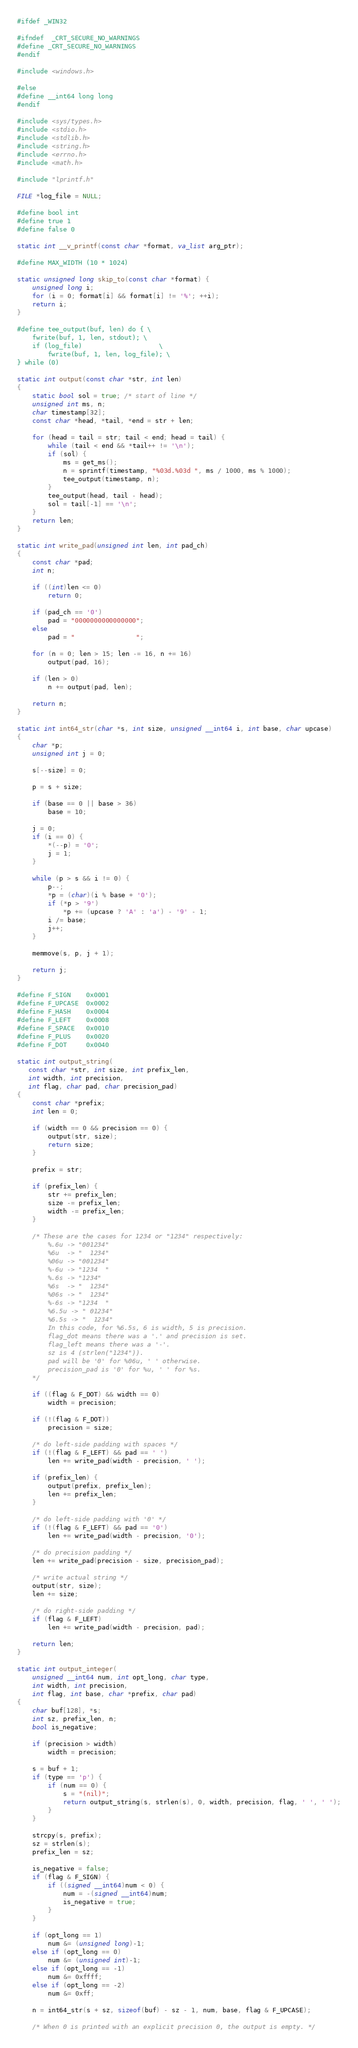Convert code to text. <code><loc_0><loc_0><loc_500><loc_500><_C_>
#ifdef _WIN32

#ifndef	_CRT_SECURE_NO_WARNINGS
#define _CRT_SECURE_NO_WARNINGS
#endif

#include <windows.h>

#else
#define __int64 long long
#endif

#include <sys/types.h>
#include <stdio.h>
#include <stdlib.h>
#include <string.h>
#include <errno.h>
#include <math.h>

#include "lprintf.h"

FILE *log_file = NULL;

#define bool int
#define true 1
#define false 0

static int __v_printf(const char *format, va_list arg_ptr);

#define MAX_WIDTH (10 * 1024)

static unsigned long skip_to(const char *format) {
    unsigned long i;
    for (i = 0; format[i] && format[i] != '%'; ++i);
    return i;
}

#define tee_output(buf, len) do { \
    fwrite(buf, 1, len, stdout); \
	if (log_file)                    \
        fwrite(buf, 1, len, log_file); \
} while (0)

static int output(const char *str, int len)
{
	static bool sol = true; /* start of line */
	unsigned int ms, n;
	char timestamp[32];
	const char *head, *tail, *end = str + len;

	for (head = tail = str; tail < end; head = tail) {
		while (tail < end && *tail++ != '\n');
		if (sol) {
			ms = get_ms();
			n = sprintf(timestamp, "%03d.%03d ", ms / 1000, ms % 1000);
			tee_output(timestamp, n);
		}
		tee_output(head, tail - head);
		sol = tail[-1] == '\n';
	}
	return len;
}

static int write_pad(unsigned int len, int pad_ch) 
{
    const char *pad;
    int n;

    if ((int)len <= 0) 
        return 0;

    if (pad_ch == '0')
        pad = "0000000000000000";
    else
        pad = "                ";

    for (n = 0; len > 15; len -= 16, n += 16) 
        output(pad, 16);

    if (len > 0) 
        n += output(pad, len); 

    return n;
}

static int int64_str(char *s, int size, unsigned __int64 i, int base, char upcase)
{
    char *p;
    unsigned int j = 0;
    
    s[--size] = 0; 
    
    p = s + size;
    
    if (base == 0 || base > 36) 
        base = 10;
    
    j = 0;
    if (i == 0) {
        *(--p) = '0';
        j = 1;
    }
    
    while (p > s && i != 0) {
        p--;
        *p = (char)(i % base + '0');
        if (*p > '9') 
            *p += (upcase ? 'A' : 'a') - '9' - 1;
        i /= base;
        j++;
    }

    memmove(s, p, j + 1);

    return j;
}

#define F_SIGN    0x0001
#define F_UPCASE  0x0002
#define F_HASH    0x0004
#define F_LEFT    0x0008
#define F_SPACE   0x0010
#define F_PLUS    0x0020
#define F_DOT     0x0040

static int output_string(
   const char *str, int size, int prefix_len, 
   int width, int precision, 
   int flag, char pad, char precision_pad)
{
    const char *prefix;
    int len = 0;

    if (width == 0 && precision == 0) {
        output(str, size); 
        return size;
    }
    
    prefix = str;
    
    if (prefix_len) {
        str += prefix_len;
        size -= prefix_len;
        width -= prefix_len;
    }
    
    /* These are the cases for 1234 or "1234" respectively:
        %.6u -> "001234"
        %6u  -> "  1234"
        %06u -> "001234"
        %-6u -> "1234  "
        %.6s -> "1234"
        %6s  -> "  1234"
        %06s -> "  1234"
        %-6s -> "1234  "
        %6.5u -> " 01234"
        %6.5s -> "  1234"
        In this code, for %6.5s, 6 is width, 5 is precision.
        flag_dot means there was a '.' and precision is set.
        flag_left means there was a '-'.
        sz is 4 (strlen("1234")).
        pad will be '0' for %06u, ' ' otherwise.
        precision_pad is '0' for %u, ' ' for %s.
    */
    
    if ((flag & F_DOT) && width == 0) 
        width = precision;
    
    if (!(flag & F_DOT)) 
        precision = size;

    /* do left-side padding with spaces */
    if (!(flag & F_LEFT) && pad == ' ') 
        len += write_pad(width - precision, ' ');
    
    if (prefix_len) {
        output(prefix, prefix_len);
        len += prefix_len;
    }

    /* do left-side padding with '0' */
    if (!(flag & F_LEFT) && pad == '0') 
        len += write_pad(width - precision, '0');
    
    /* do precision padding */
    len += write_pad(precision - size, precision_pad);
    
    /* write actual string */
    output(str, size); 
    len += size;

    /* do right-side padding */
    if (flag & F_LEFT) 
        len += write_pad(width - precision, pad);

    return len;
}

static int output_integer(
    unsigned __int64 num, int opt_long, char type, 
    int width, int precision, 
    int flag, int base, char *prefix, char pad)
{
    char buf[128], *s;
    int sz, prefix_len, n;
    bool is_negative;

    if (precision > width) 
        width = precision;
    
    s = buf + 1;
    if (type == 'p') {
        if (num == 0) {
            s = "(nil)";
            return output_string(s, strlen(s), 0, width, precision, flag, ' ', ' ');
        } 
    } 

    strcpy(s, prefix);
    sz = strlen(s);
    prefix_len = sz;

    is_negative = false;
    if (flag & F_SIGN) {
        if ((signed __int64)num < 0) {
            num = -(signed __int64)num;
            is_negative = true;
        }
    } 
    
    if (opt_long == 1)
        num &= (unsigned long)-1;
    else if (opt_long == 0)
        num &= (unsigned int)-1;
    else if (opt_long == -1) 
        num &= 0xffff;
    else if (opt_long == -2) 
        num &= 0xff;

    n = int64_str(s + sz, sizeof(buf) - sz - 1, num, base, flag & F_UPCASE);

    /* When 0 is printed with an explicit precision 0, the output is empty. */</code> 